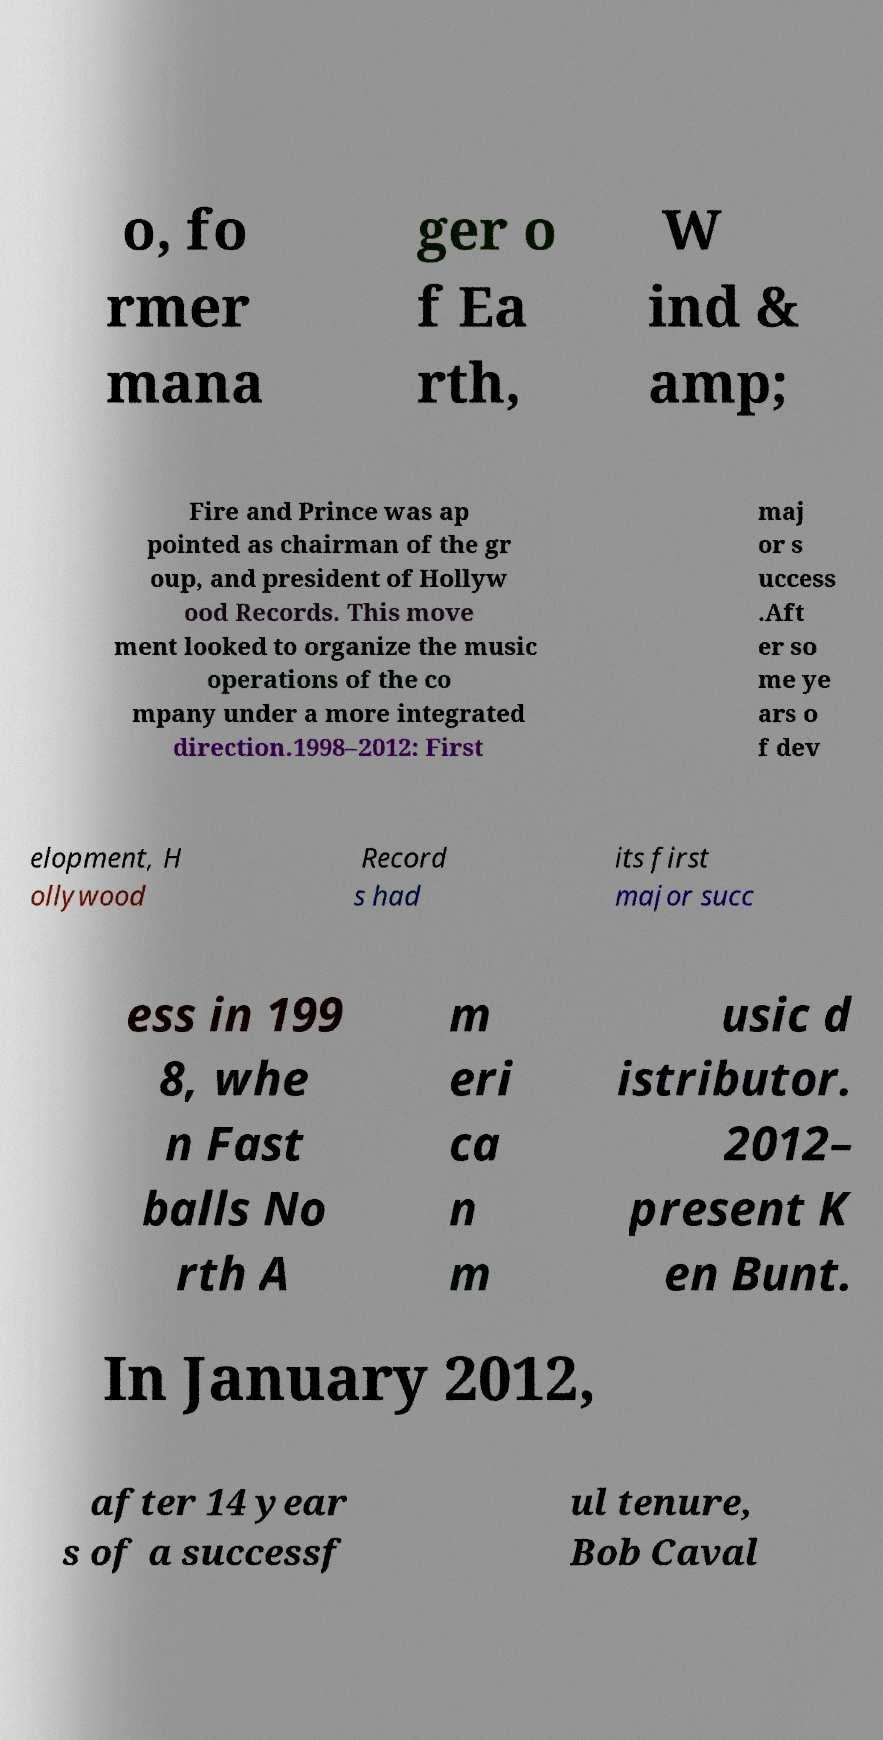Can you accurately transcribe the text from the provided image for me? o, fo rmer mana ger o f Ea rth, W ind & amp; Fire and Prince was ap pointed as chairman of the gr oup, and president of Hollyw ood Records. This move ment looked to organize the music operations of the co mpany under a more integrated direction.1998–2012: First maj or s uccess .Aft er so me ye ars o f dev elopment, H ollywood Record s had its first major succ ess in 199 8, whe n Fast balls No rth A m eri ca n m usic d istributor. 2012– present K en Bunt. In January 2012, after 14 year s of a successf ul tenure, Bob Caval 